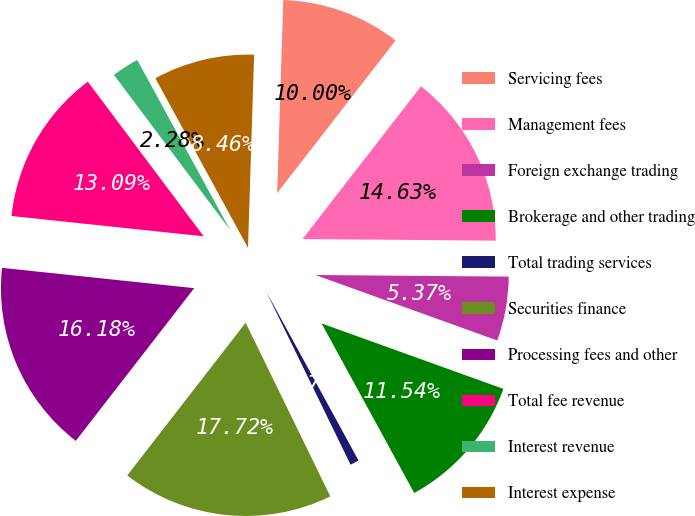Convert chart. <chart><loc_0><loc_0><loc_500><loc_500><pie_chart><fcel>Servicing fees<fcel>Management fees<fcel>Foreign exchange trading<fcel>Brokerage and other trading<fcel>Total trading services<fcel>Securities finance<fcel>Processing fees and other<fcel>Total fee revenue<fcel>Interest revenue<fcel>Interest expense<nl><fcel>10.0%<fcel>14.63%<fcel>5.37%<fcel>11.54%<fcel>0.74%<fcel>17.72%<fcel>16.18%<fcel>13.09%<fcel>2.28%<fcel>8.46%<nl></chart> 